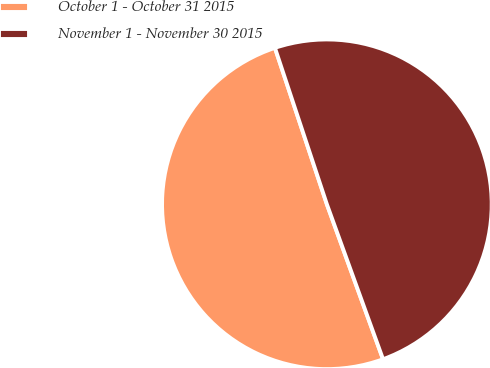Convert chart. <chart><loc_0><loc_0><loc_500><loc_500><pie_chart><fcel>October 1 - October 31 2015<fcel>November 1 - November 30 2015<nl><fcel>50.43%<fcel>49.57%<nl></chart> 